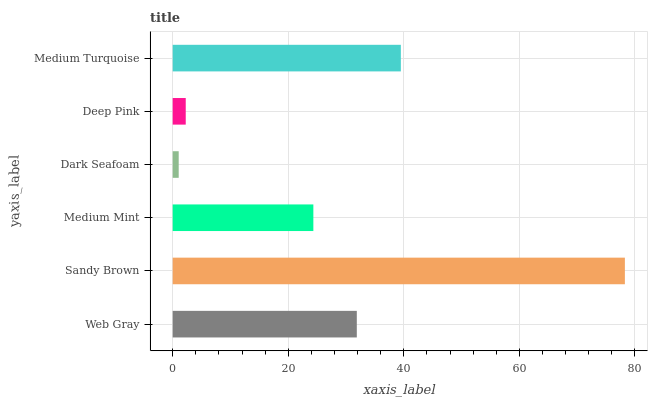Is Dark Seafoam the minimum?
Answer yes or no. Yes. Is Sandy Brown the maximum?
Answer yes or no. Yes. Is Medium Mint the minimum?
Answer yes or no. No. Is Medium Mint the maximum?
Answer yes or no. No. Is Sandy Brown greater than Medium Mint?
Answer yes or no. Yes. Is Medium Mint less than Sandy Brown?
Answer yes or no. Yes. Is Medium Mint greater than Sandy Brown?
Answer yes or no. No. Is Sandy Brown less than Medium Mint?
Answer yes or no. No. Is Web Gray the high median?
Answer yes or no. Yes. Is Medium Mint the low median?
Answer yes or no. Yes. Is Sandy Brown the high median?
Answer yes or no. No. Is Web Gray the low median?
Answer yes or no. No. 